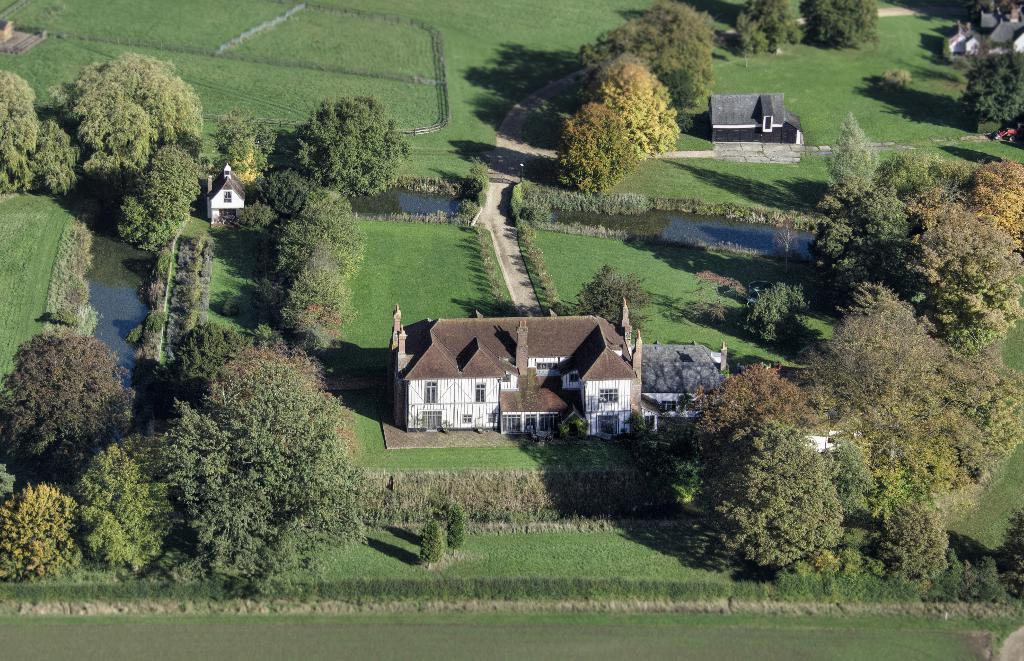What type of vegetation can be seen in the image? There are trees and plants in the image. What is on the ground in the image? There is grass on the ground in the image. What type of structures are present in the image? There are houses in the image. What natural element can be seen in the image? There is water visible in the image. What feature is present in front of the house? There is a path in front of the house. What type of popcorn is being used to decorate the trees in the image? There is no popcorn present in the image, and therefore no such decoration can be observed. 